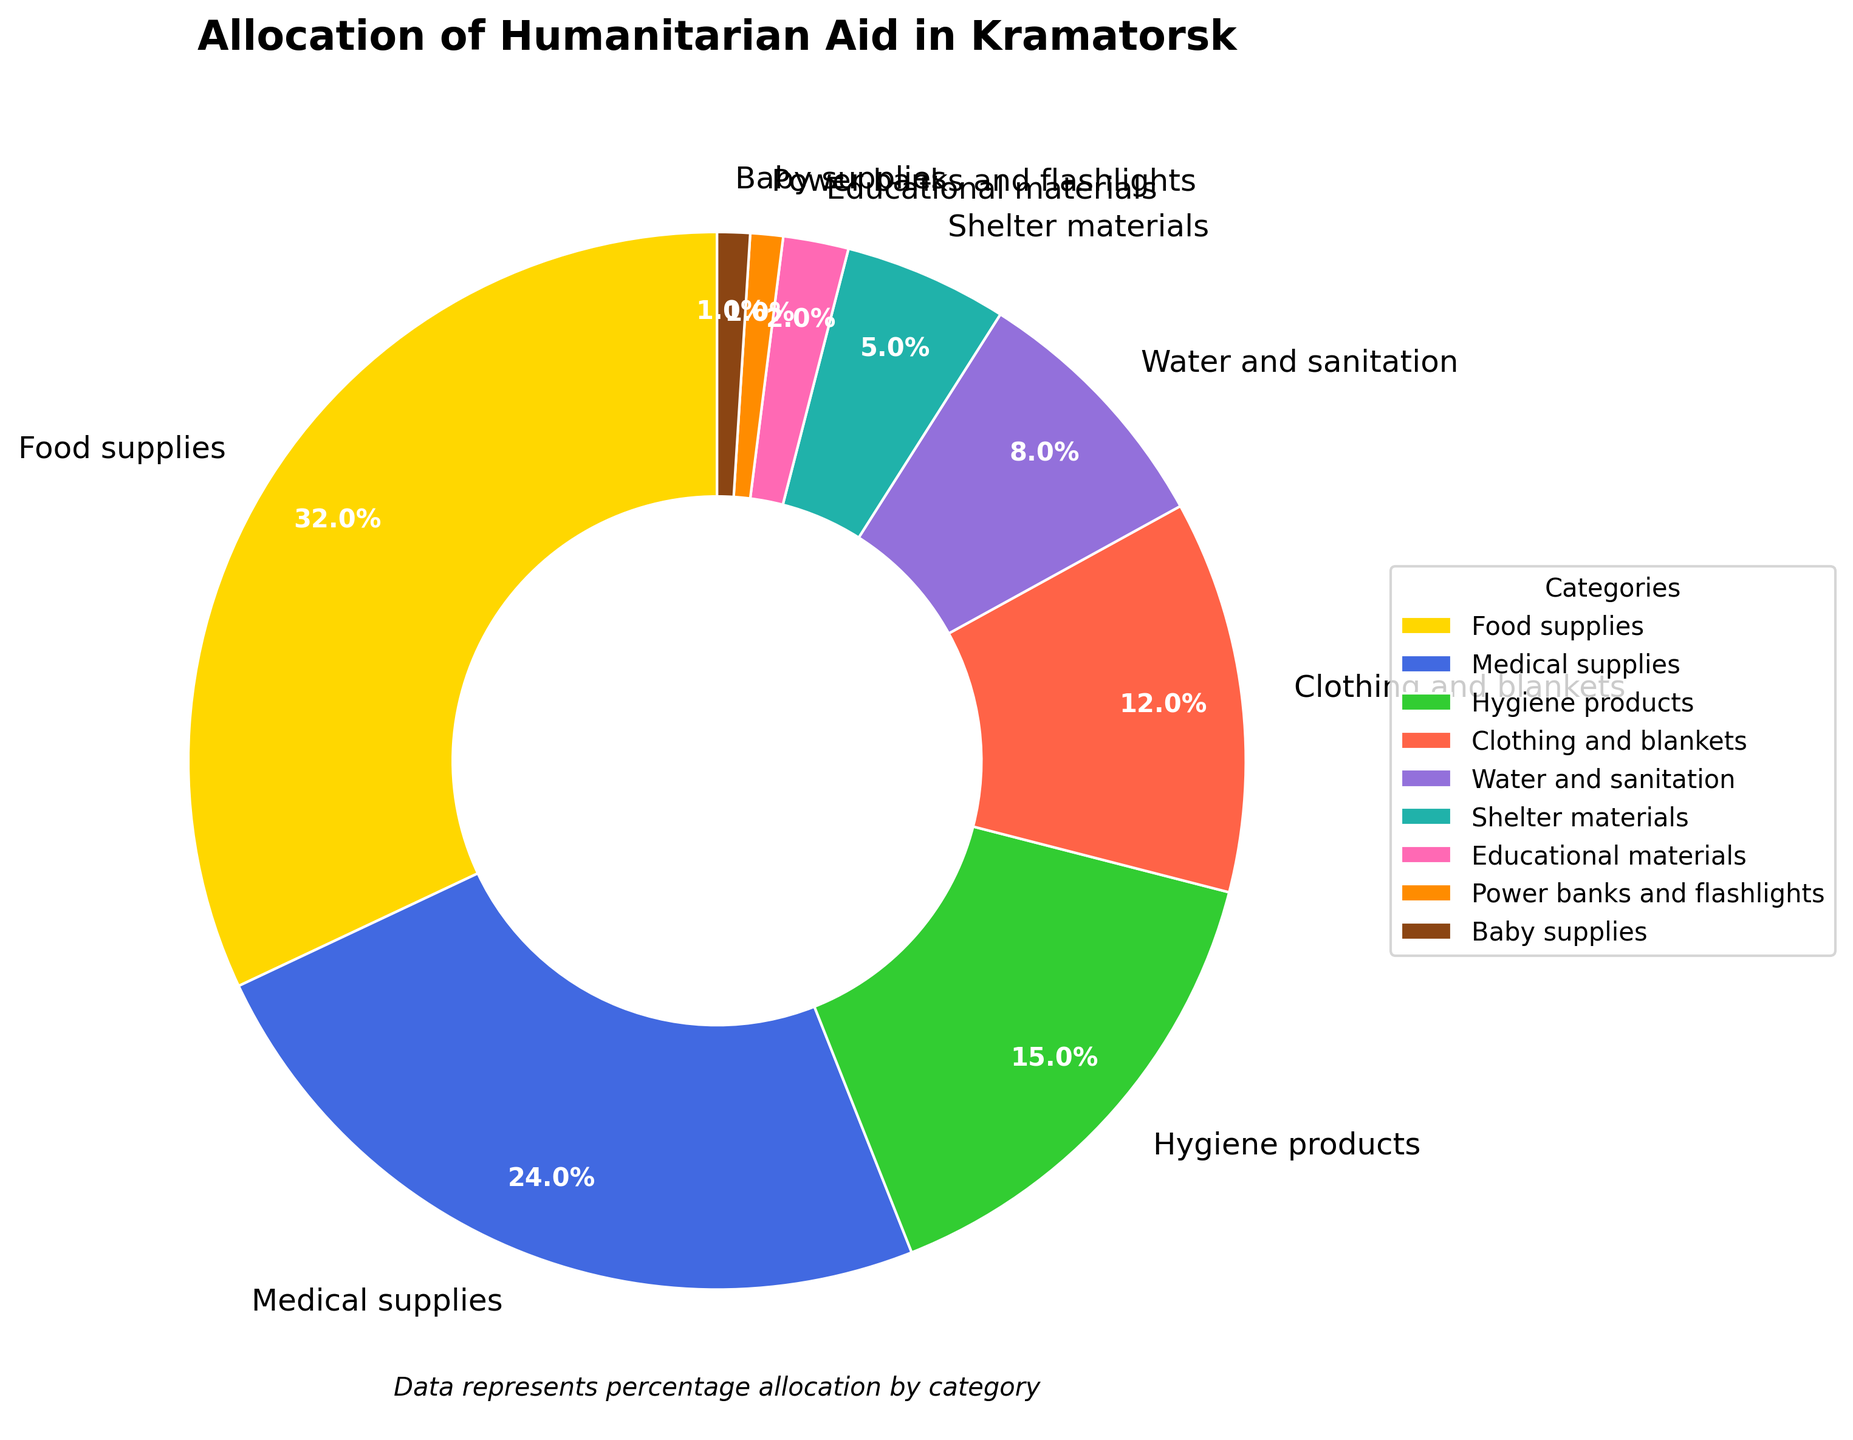What category receives the highest percentage of aid? The category with the highest percentage of aid can be identified by looking for the largest segment in the pie chart. In this case, it is clearly labeled and visually prominent.
Answer: Food supplies Which categories combined make up half of the total aid? We need to find categories whose percentages add up to 50%. Combining Food supplies (32%) and Medical supplies (24%) gives 56%, which is more than half. Therefore, these two categories combined make up more than half of the aid.
Answer: Food supplies and Medical supplies How does the percentage allocated to Hygiene products compare to that allocated to Clothing and blankets? The pie chart shows that Hygiene products have a percentage of 15%, while Clothing and blankets have 12%. By comparing these two values, we see that Hygiene products receive a slightly higher percentage.
Answer: Hygiene products receive a higher percentage What is the total percentage allocated to categories related to basic needs (Food supplies, Medical supplies, Hygiene products)? To find this, we sum the percentages of Food supplies (32%), Medical supplies (24%), and Hygiene products (15%). The total is 32 + 24 + 15 = 71%.
Answer: 71% Which category receives the least allocation, and what is its percentage? By observing the smallest segment in the pie chart and corresponding label, we can identify the category with the least allocation. In this case, it is Baby supplies with 1%.
Answer: Baby supplies, 1% What is the combined percentage of aid allocated to Shelter materials and Educational materials? Adding the percentages of Shelter materials (5%) and Educational materials (2%) gives a total of 5 + 2 = 7%.
Answer: 7% Compare the percentage of aid allocated to Water and sanitation vs Power banks and flashlights. Water and sanitation receive 8% of the aid, whereas Power banks and flashlights receive 1%. By comparing these values, we see that Water and sanitation receive a significantly higher percentage of the aid.
Answer: Water and sanitation receive more If the percentages of Medical supplies and Hygiene products were halved, what would be the new percentages for these categories? Halving the percentage of Medical supplies (24%) results in 24 / 2 = 12%. Halving the percentage of Hygiene products (15%) results in 15 / 2 = 7.5%.
Answer: Medical supplies: 12%, Hygiene products: 7.5% What percentage of aid is allocated to categories other than Food supplies and Medical supplies? Subtract the sum of percentages for Food supplies (32%) and Medical supplies (24%) from 100%. The calculation is 100 - (32 + 24) = 100 - 56 = 44%.
Answer: 44% Which three categories receive the least amount of aid? By looking at the pie chart segments and their corresponding percentages, the three categories with the smallest percentages are Baby supplies (1%), Power banks and flashlights (1%), and Educational materials (2%).
Answer: Baby supplies, Power banks and flashlights, Educational materials 